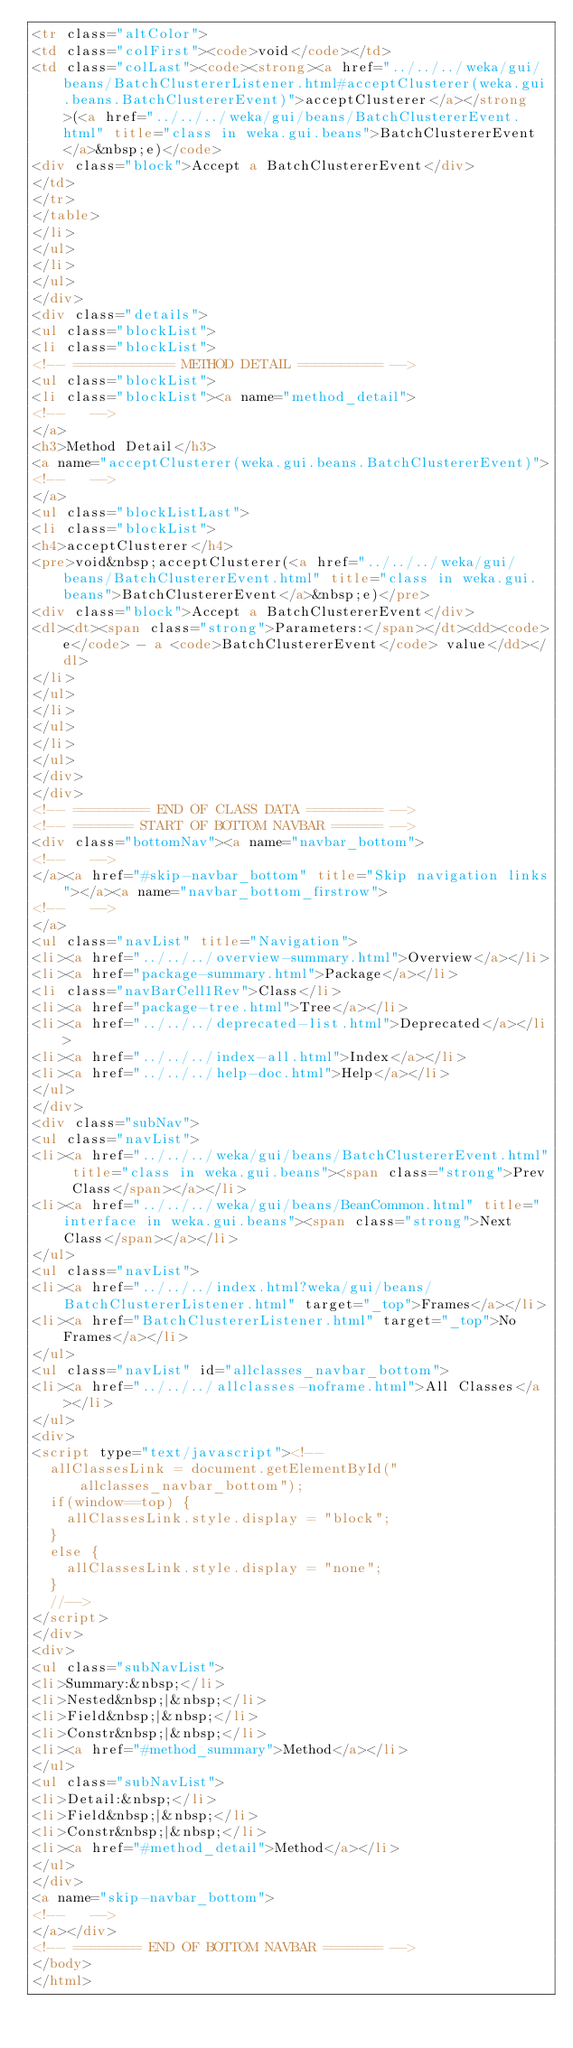<code> <loc_0><loc_0><loc_500><loc_500><_HTML_><tr class="altColor">
<td class="colFirst"><code>void</code></td>
<td class="colLast"><code><strong><a href="../../../weka/gui/beans/BatchClustererListener.html#acceptClusterer(weka.gui.beans.BatchClustererEvent)">acceptClusterer</a></strong>(<a href="../../../weka/gui/beans/BatchClustererEvent.html" title="class in weka.gui.beans">BatchClustererEvent</a>&nbsp;e)</code>
<div class="block">Accept a BatchClustererEvent</div>
</td>
</tr>
</table>
</li>
</ul>
</li>
</ul>
</div>
<div class="details">
<ul class="blockList">
<li class="blockList">
<!-- ============ METHOD DETAIL ========== -->
<ul class="blockList">
<li class="blockList"><a name="method_detail">
<!--   -->
</a>
<h3>Method Detail</h3>
<a name="acceptClusterer(weka.gui.beans.BatchClustererEvent)">
<!--   -->
</a>
<ul class="blockListLast">
<li class="blockList">
<h4>acceptClusterer</h4>
<pre>void&nbsp;acceptClusterer(<a href="../../../weka/gui/beans/BatchClustererEvent.html" title="class in weka.gui.beans">BatchClustererEvent</a>&nbsp;e)</pre>
<div class="block">Accept a BatchClustererEvent</div>
<dl><dt><span class="strong">Parameters:</span></dt><dd><code>e</code> - a <code>BatchClustererEvent</code> value</dd></dl>
</li>
</ul>
</li>
</ul>
</li>
</ul>
</div>
</div>
<!-- ========= END OF CLASS DATA ========= -->
<!-- ======= START OF BOTTOM NAVBAR ====== -->
<div class="bottomNav"><a name="navbar_bottom">
<!--   -->
</a><a href="#skip-navbar_bottom" title="Skip navigation links"></a><a name="navbar_bottom_firstrow">
<!--   -->
</a>
<ul class="navList" title="Navigation">
<li><a href="../../../overview-summary.html">Overview</a></li>
<li><a href="package-summary.html">Package</a></li>
<li class="navBarCell1Rev">Class</li>
<li><a href="package-tree.html">Tree</a></li>
<li><a href="../../../deprecated-list.html">Deprecated</a></li>
<li><a href="../../../index-all.html">Index</a></li>
<li><a href="../../../help-doc.html">Help</a></li>
</ul>
</div>
<div class="subNav">
<ul class="navList">
<li><a href="../../../weka/gui/beans/BatchClustererEvent.html" title="class in weka.gui.beans"><span class="strong">Prev Class</span></a></li>
<li><a href="../../../weka/gui/beans/BeanCommon.html" title="interface in weka.gui.beans"><span class="strong">Next Class</span></a></li>
</ul>
<ul class="navList">
<li><a href="../../../index.html?weka/gui/beans/BatchClustererListener.html" target="_top">Frames</a></li>
<li><a href="BatchClustererListener.html" target="_top">No Frames</a></li>
</ul>
<ul class="navList" id="allclasses_navbar_bottom">
<li><a href="../../../allclasses-noframe.html">All Classes</a></li>
</ul>
<div>
<script type="text/javascript"><!--
  allClassesLink = document.getElementById("allclasses_navbar_bottom");
  if(window==top) {
    allClassesLink.style.display = "block";
  }
  else {
    allClassesLink.style.display = "none";
  }
  //-->
</script>
</div>
<div>
<ul class="subNavList">
<li>Summary:&nbsp;</li>
<li>Nested&nbsp;|&nbsp;</li>
<li>Field&nbsp;|&nbsp;</li>
<li>Constr&nbsp;|&nbsp;</li>
<li><a href="#method_summary">Method</a></li>
</ul>
<ul class="subNavList">
<li>Detail:&nbsp;</li>
<li>Field&nbsp;|&nbsp;</li>
<li>Constr&nbsp;|&nbsp;</li>
<li><a href="#method_detail">Method</a></li>
</ul>
</div>
<a name="skip-navbar_bottom">
<!--   -->
</a></div>
<!-- ======== END OF BOTTOM NAVBAR ======= -->
</body>
</html>
</code> 